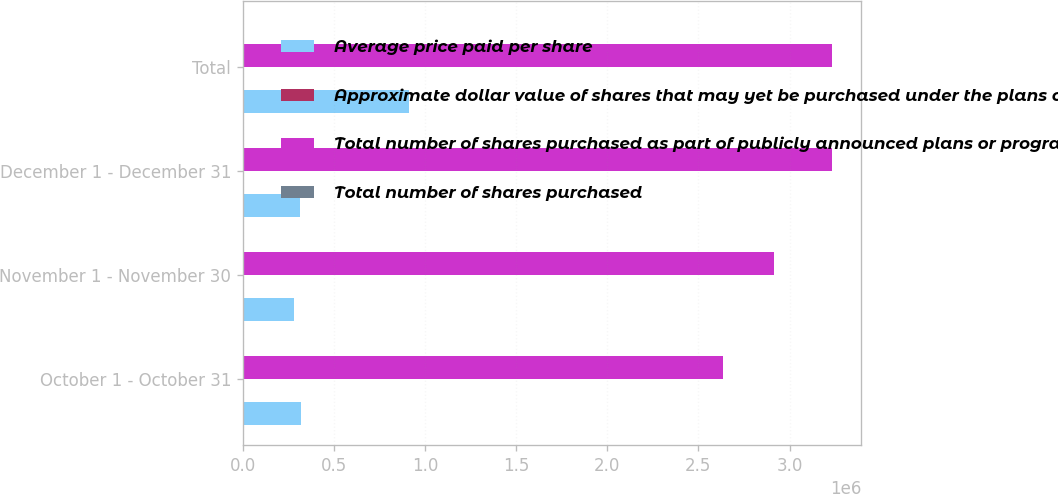Convert chart. <chart><loc_0><loc_0><loc_500><loc_500><stacked_bar_chart><ecel><fcel>October 1 - October 31<fcel>November 1 - November 30<fcel>December 1 - December 31<fcel>Total<nl><fcel>Average price paid per share<fcel>319500<fcel>279600<fcel>315700<fcel>914800<nl><fcel>Approximate dollar value of shares that may yet be purchased under the plans or programs in millions1<fcel>201.69<fcel>219.94<fcel>223.23<fcel>215.14<nl><fcel>Total number of shares purchased as part of publicly announced plans or programs1<fcel>2.63618e+06<fcel>2.91578e+06<fcel>3.23148e+06<fcel>3.23148e+06<nl><fcel>Total number of shares purchased<fcel>537<fcel>475<fcel>405<fcel>405<nl></chart> 